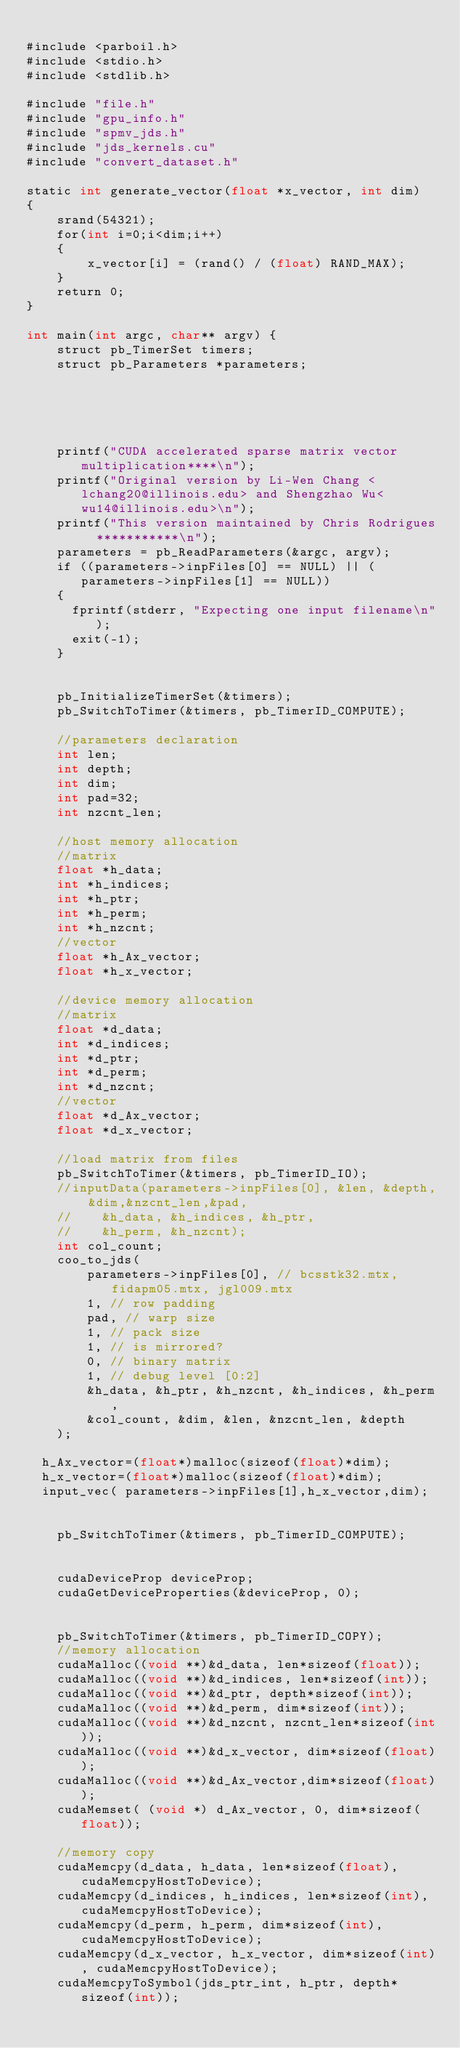<code> <loc_0><loc_0><loc_500><loc_500><_Cuda_>
#include <parboil.h>
#include <stdio.h>
#include <stdlib.h>

#include "file.h"
#include "gpu_info.h"
#include "spmv_jds.h"
#include "jds_kernels.cu"
#include "convert_dataset.h"

static int generate_vector(float *x_vector, int dim) 
{	
	srand(54321);	
	for(int i=0;i<dim;i++)
	{
		x_vector[i] = (rand() / (float) RAND_MAX);
	}
	return 0;
}

int main(int argc, char** argv) {
	struct pb_TimerSet timers;
	struct pb_Parameters *parameters;
	
	
	
	
	
	printf("CUDA accelerated sparse matrix vector multiplication****\n");
	printf("Original version by Li-Wen Chang <lchang20@illinois.edu> and Shengzhao Wu<wu14@illinois.edu>\n");
	printf("This version maintained by Chris Rodrigues  ***********\n");
	parameters = pb_ReadParameters(&argc, argv);
	if ((parameters->inpFiles[0] == NULL) || (parameters->inpFiles[1] == NULL))
    {
      fprintf(stderr, "Expecting one input filename\n");
      exit(-1);
    }

	
	pb_InitializeTimerSet(&timers);
	pb_SwitchToTimer(&timers, pb_TimerID_COMPUTE);
	
	//parameters declaration
	int len;
	int depth;
	int dim;
	int pad=32;
	int nzcnt_len;
	
	//host memory allocation
	//matrix
	float *h_data;
	int *h_indices;
	int *h_ptr;
	int *h_perm;
	int *h_nzcnt;
	//vector
	float *h_Ax_vector;
    float *h_x_vector;
	
	//device memory allocation
	//matrix
	float *d_data;
	int *d_indices;
	int *d_ptr;
	int *d_perm;
	int *d_nzcnt;
	//vector
	float *d_Ax_vector;
    float *d_x_vector;
	
    //load matrix from files
	pb_SwitchToTimer(&timers, pb_TimerID_IO);
	//inputData(parameters->inpFiles[0], &len, &depth, &dim,&nzcnt_len,&pad,
	//    &h_data, &h_indices, &h_ptr,
	//    &h_perm, &h_nzcnt);
	int col_count;
	coo_to_jds(
		parameters->inpFiles[0], // bcsstk32.mtx, fidapm05.mtx, jgl009.mtx
		1, // row padding
		pad, // warp size
		1, // pack size
		1, // is mirrored?
		0, // binary matrix
		1, // debug level [0:2]
		&h_data, &h_ptr, &h_nzcnt, &h_indices, &h_perm,
		&col_count, &dim, &len, &nzcnt_len, &depth
	);
	
  h_Ax_vector=(float*)malloc(sizeof(float)*dim);
  h_x_vector=(float*)malloc(sizeof(float)*dim);
  input_vec( parameters->inpFiles[1],h_x_vector,dim);


	pb_SwitchToTimer(&timers, pb_TimerID_COMPUTE);

	
	cudaDeviceProp deviceProp;
    cudaGetDeviceProperties(&deviceProp, 0);
	
	
	pb_SwitchToTimer(&timers, pb_TimerID_COPY);
	//memory allocation
	cudaMalloc((void **)&d_data, len*sizeof(float));
	cudaMalloc((void **)&d_indices, len*sizeof(int));
	cudaMalloc((void **)&d_ptr, depth*sizeof(int));
	cudaMalloc((void **)&d_perm, dim*sizeof(int));
	cudaMalloc((void **)&d_nzcnt, nzcnt_len*sizeof(int));
	cudaMalloc((void **)&d_x_vector, dim*sizeof(float));
	cudaMalloc((void **)&d_Ax_vector,dim*sizeof(float));
	cudaMemset( (void *) d_Ax_vector, 0, dim*sizeof(float));
	
	//memory copy
	cudaMemcpy(d_data, h_data, len*sizeof(float), cudaMemcpyHostToDevice);
	cudaMemcpy(d_indices, h_indices, len*sizeof(int), cudaMemcpyHostToDevice);
	cudaMemcpy(d_perm, h_perm, dim*sizeof(int), cudaMemcpyHostToDevice);
	cudaMemcpy(d_x_vector, h_x_vector, dim*sizeof(int), cudaMemcpyHostToDevice);
	cudaMemcpyToSymbol(jds_ptr_int, h_ptr, depth*sizeof(int));</code> 